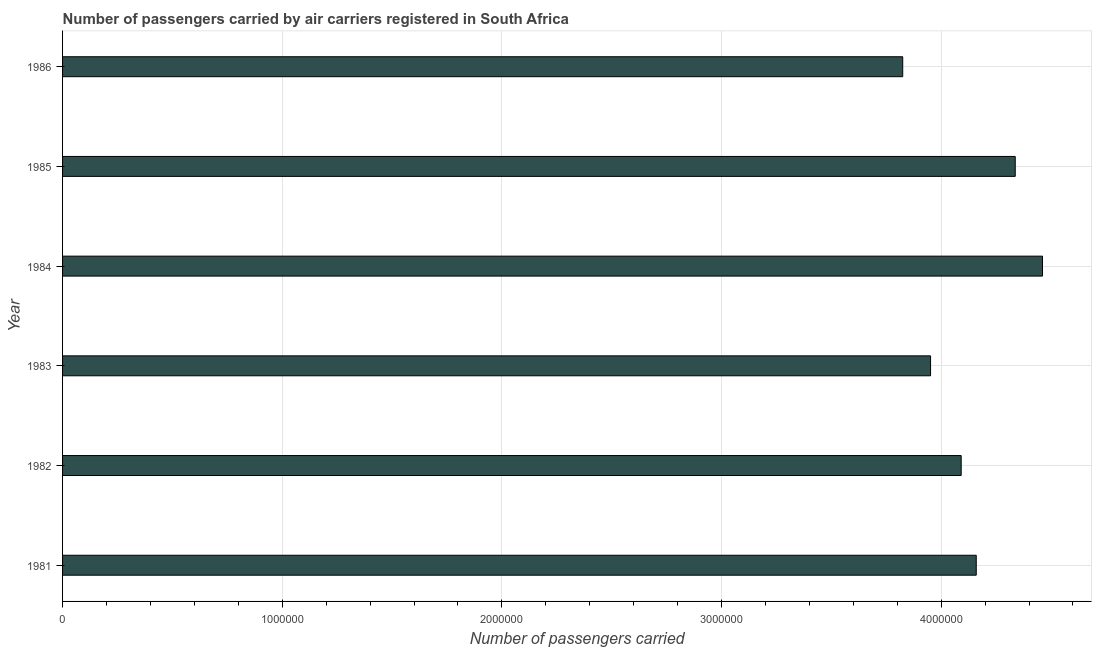Does the graph contain any zero values?
Your answer should be compact. No. Does the graph contain grids?
Your response must be concise. Yes. What is the title of the graph?
Provide a succinct answer. Number of passengers carried by air carriers registered in South Africa. What is the label or title of the X-axis?
Ensure brevity in your answer.  Number of passengers carried. What is the number of passengers carried in 1985?
Give a very brief answer. 4.34e+06. Across all years, what is the maximum number of passengers carried?
Give a very brief answer. 4.46e+06. Across all years, what is the minimum number of passengers carried?
Make the answer very short. 3.82e+06. What is the sum of the number of passengers carried?
Provide a succinct answer. 2.48e+07. What is the difference between the number of passengers carried in 1983 and 1986?
Ensure brevity in your answer.  1.27e+05. What is the average number of passengers carried per year?
Keep it short and to the point. 4.14e+06. What is the median number of passengers carried?
Make the answer very short. 4.13e+06. What is the ratio of the number of passengers carried in 1981 to that in 1983?
Make the answer very short. 1.05. Is the number of passengers carried in 1982 less than that in 1985?
Provide a short and direct response. Yes. Is the difference between the number of passengers carried in 1984 and 1986 greater than the difference between any two years?
Provide a succinct answer. Yes. What is the difference between the highest and the second highest number of passengers carried?
Keep it short and to the point. 1.24e+05. Is the sum of the number of passengers carried in 1981 and 1982 greater than the maximum number of passengers carried across all years?
Offer a terse response. Yes. What is the difference between the highest and the lowest number of passengers carried?
Provide a short and direct response. 6.36e+05. In how many years, is the number of passengers carried greater than the average number of passengers carried taken over all years?
Give a very brief answer. 3. How many bars are there?
Your response must be concise. 6. Are all the bars in the graph horizontal?
Your answer should be compact. Yes. What is the Number of passengers carried of 1981?
Provide a short and direct response. 4.16e+06. What is the Number of passengers carried of 1982?
Give a very brief answer. 4.09e+06. What is the Number of passengers carried in 1983?
Keep it short and to the point. 3.95e+06. What is the Number of passengers carried of 1984?
Offer a very short reply. 4.46e+06. What is the Number of passengers carried of 1985?
Offer a terse response. 4.34e+06. What is the Number of passengers carried of 1986?
Ensure brevity in your answer.  3.82e+06. What is the difference between the Number of passengers carried in 1981 and 1982?
Offer a terse response. 6.86e+04. What is the difference between the Number of passengers carried in 1981 and 1983?
Give a very brief answer. 2.08e+05. What is the difference between the Number of passengers carried in 1981 and 1984?
Offer a very short reply. -3.02e+05. What is the difference between the Number of passengers carried in 1981 and 1985?
Provide a succinct answer. -1.78e+05. What is the difference between the Number of passengers carried in 1981 and 1986?
Your response must be concise. 3.35e+05. What is the difference between the Number of passengers carried in 1982 and 1983?
Ensure brevity in your answer.  1.39e+05. What is the difference between the Number of passengers carried in 1982 and 1984?
Your answer should be compact. -3.70e+05. What is the difference between the Number of passengers carried in 1982 and 1985?
Ensure brevity in your answer.  -2.46e+05. What is the difference between the Number of passengers carried in 1982 and 1986?
Make the answer very short. 2.66e+05. What is the difference between the Number of passengers carried in 1983 and 1984?
Your response must be concise. -5.10e+05. What is the difference between the Number of passengers carried in 1983 and 1985?
Provide a short and direct response. -3.86e+05. What is the difference between the Number of passengers carried in 1983 and 1986?
Your answer should be very brief. 1.27e+05. What is the difference between the Number of passengers carried in 1984 and 1985?
Keep it short and to the point. 1.24e+05. What is the difference between the Number of passengers carried in 1984 and 1986?
Offer a very short reply. 6.36e+05. What is the difference between the Number of passengers carried in 1985 and 1986?
Your answer should be very brief. 5.12e+05. What is the ratio of the Number of passengers carried in 1981 to that in 1982?
Ensure brevity in your answer.  1.02. What is the ratio of the Number of passengers carried in 1981 to that in 1983?
Offer a very short reply. 1.05. What is the ratio of the Number of passengers carried in 1981 to that in 1984?
Your answer should be compact. 0.93. What is the ratio of the Number of passengers carried in 1981 to that in 1986?
Your response must be concise. 1.09. What is the ratio of the Number of passengers carried in 1982 to that in 1983?
Ensure brevity in your answer.  1.03. What is the ratio of the Number of passengers carried in 1982 to that in 1984?
Make the answer very short. 0.92. What is the ratio of the Number of passengers carried in 1982 to that in 1985?
Make the answer very short. 0.94. What is the ratio of the Number of passengers carried in 1982 to that in 1986?
Ensure brevity in your answer.  1.07. What is the ratio of the Number of passengers carried in 1983 to that in 1984?
Your answer should be very brief. 0.89. What is the ratio of the Number of passengers carried in 1983 to that in 1985?
Your answer should be compact. 0.91. What is the ratio of the Number of passengers carried in 1983 to that in 1986?
Provide a succinct answer. 1.03. What is the ratio of the Number of passengers carried in 1984 to that in 1986?
Keep it short and to the point. 1.17. What is the ratio of the Number of passengers carried in 1985 to that in 1986?
Offer a terse response. 1.13. 